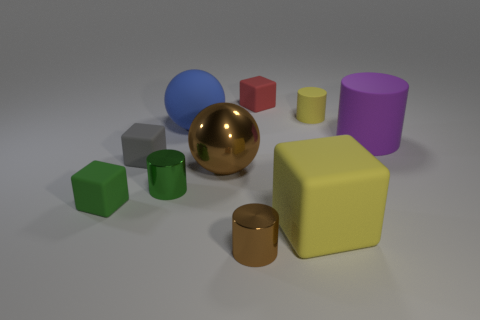Can you describe the colors and shapes of the objects in the image? Certainly! There is a variety of geometric shapes in multiple colors: a large yellow cube, a smaller green cube, a red cube, two cylinders—one yellow, one brown—and a large brown sphere. There's also a smaller blue sphere and a purple cylinder with a matte finish. Each object has a smooth, clean look, and they're arranged on a neutral background. 